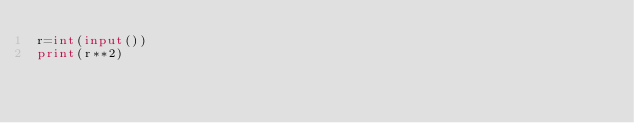Convert code to text. <code><loc_0><loc_0><loc_500><loc_500><_Python_>r=int(input())
print(r**2)
</code> 